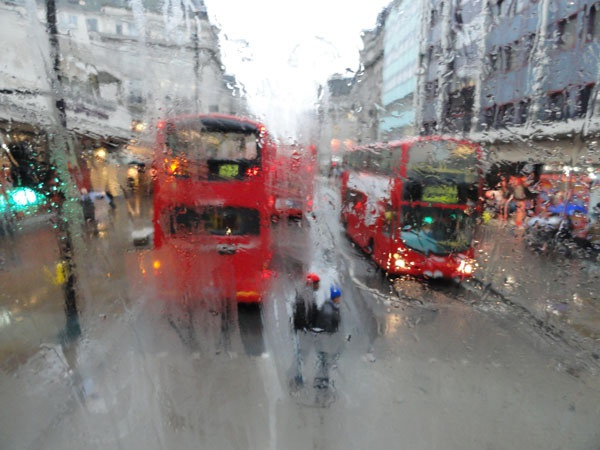Describe the objects in this image and their specific colors. I can see bus in darkgray, brown, black, and gray tones, bus in darkgray, gray, black, and brown tones, bus in darkgray, brown, lightpink, and salmon tones, people in darkgray, gray, and black tones, and traffic light in darkgray, black, gray, white, and teal tones in this image. 